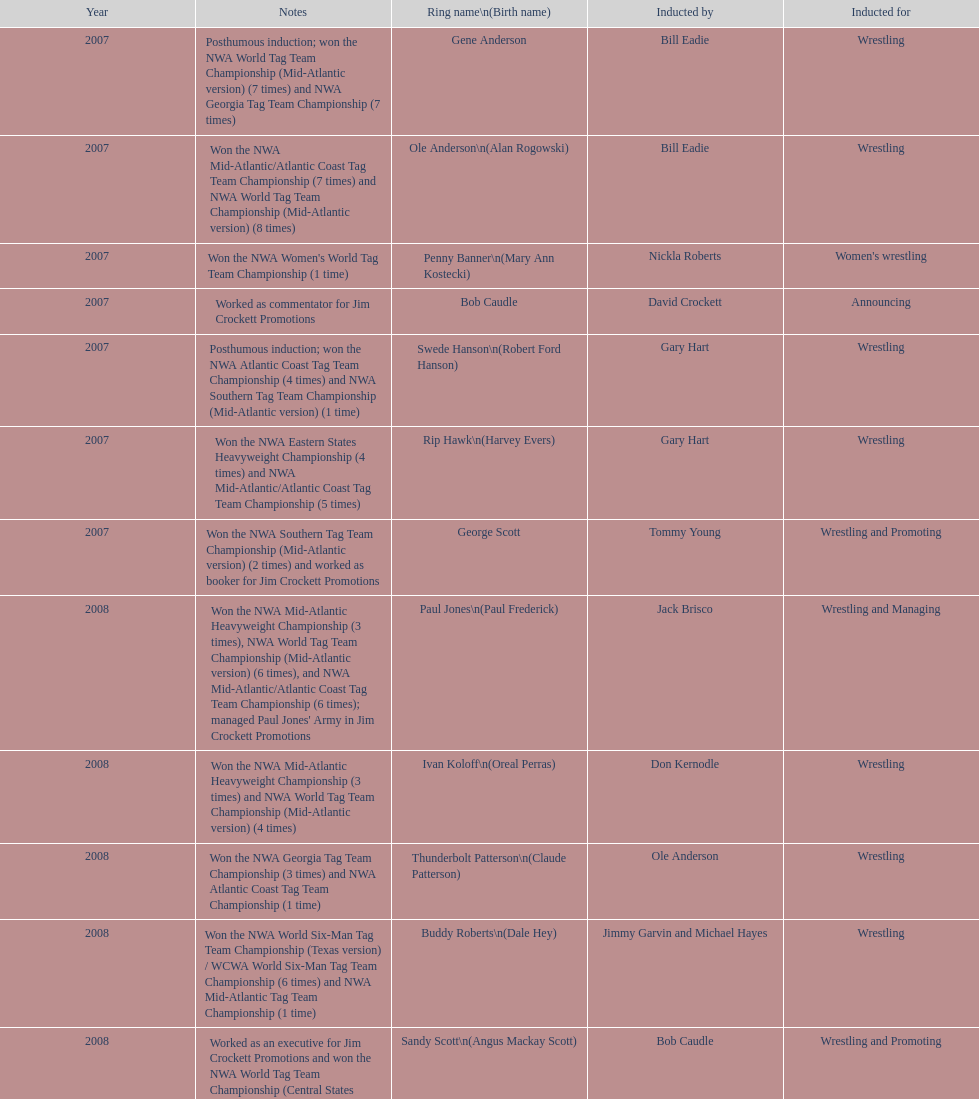Give me the full table as a dictionary. {'header': ['Year', 'Notes', 'Ring name\\n(Birth name)', 'Inducted by', 'Inducted for'], 'rows': [['2007', 'Posthumous induction; won the NWA World Tag Team Championship (Mid-Atlantic version) (7 times) and NWA Georgia Tag Team Championship (7 times)', 'Gene Anderson', 'Bill Eadie', 'Wrestling'], ['2007', 'Won the NWA Mid-Atlantic/Atlantic Coast Tag Team Championship (7 times) and NWA World Tag Team Championship (Mid-Atlantic version) (8 times)', 'Ole Anderson\\n(Alan Rogowski)', 'Bill Eadie', 'Wrestling'], ['2007', "Won the NWA Women's World Tag Team Championship (1 time)", 'Penny Banner\\n(Mary Ann Kostecki)', 'Nickla Roberts', "Women's wrestling"], ['2007', 'Worked as commentator for Jim Crockett Promotions', 'Bob Caudle', 'David Crockett', 'Announcing'], ['2007', 'Posthumous induction; won the NWA Atlantic Coast Tag Team Championship (4 times) and NWA Southern Tag Team Championship (Mid-Atlantic version) (1 time)', 'Swede Hanson\\n(Robert Ford Hanson)', 'Gary Hart', 'Wrestling'], ['2007', 'Won the NWA Eastern States Heavyweight Championship (4 times) and NWA Mid-Atlantic/Atlantic Coast Tag Team Championship (5 times)', 'Rip Hawk\\n(Harvey Evers)', 'Gary Hart', 'Wrestling'], ['2007', 'Won the NWA Southern Tag Team Championship (Mid-Atlantic version) (2 times) and worked as booker for Jim Crockett Promotions', 'George Scott', 'Tommy Young', 'Wrestling and Promoting'], ['2008', "Won the NWA Mid-Atlantic Heavyweight Championship (3 times), NWA World Tag Team Championship (Mid-Atlantic version) (6 times), and NWA Mid-Atlantic/Atlantic Coast Tag Team Championship (6 times); managed Paul Jones' Army in Jim Crockett Promotions", 'Paul Jones\\n(Paul Frederick)', 'Jack Brisco', 'Wrestling and Managing'], ['2008', 'Won the NWA Mid-Atlantic Heavyweight Championship (3 times) and NWA World Tag Team Championship (Mid-Atlantic version) (4 times)', 'Ivan Koloff\\n(Oreal Perras)', 'Don Kernodle', 'Wrestling'], ['2008', 'Won the NWA Georgia Tag Team Championship (3 times) and NWA Atlantic Coast Tag Team Championship (1 time)', 'Thunderbolt Patterson\\n(Claude Patterson)', 'Ole Anderson', 'Wrestling'], ['2008', 'Won the NWA World Six-Man Tag Team Championship (Texas version) / WCWA World Six-Man Tag Team Championship (6 times) and NWA Mid-Atlantic Tag Team Championship (1 time)', 'Buddy Roberts\\n(Dale Hey)', 'Jimmy Garvin and Michael Hayes', 'Wrestling'], ['2008', 'Worked as an executive for Jim Crockett Promotions and won the NWA World Tag Team Championship (Central States version) (1 time) and NWA Southern Tag Team Championship (Mid-Atlantic version) (3 times)', 'Sandy Scott\\n(Angus Mackay Scott)', 'Bob Caudle', 'Wrestling and Promoting'], ['2008', 'Won the NWA United States Tag Team Championship (Tri-State version) (2 times) and NWA Texas Heavyweight Championship (1 time)', 'Grizzly Smith\\n(Aurelian Smith)', 'Magnum T.A.', 'Wrestling'], ['2008', 'Posthumous induction; won the NWA Atlantic Coast/Mid-Atlantic Tag Team Championship (8 times) and NWA Southern Tag Team Championship (Mid-Atlantic version) (6 times)', 'Johnny Weaver\\n(Kenneth Eugene Weaver)', 'Rip Hawk', 'Wrestling'], ['2009', 'Won the NWA Southern Tag Team Championship (Mid-America version) (2 times) and NWA World Tag Team Championship (Mid-America version) (6 times)', 'Don Fargo\\n(Don Kalt)', 'Jerry Jarrett & Steve Keirn', 'Wrestling'], ['2009', 'Won the NWA World Tag Team Championship (Mid-America version) (10 times) and NWA Southern Tag Team Championship (Mid-America version) (22 times)', 'Jackie Fargo\\n(Henry Faggart)', 'Jerry Jarrett & Steve Keirn', 'Wrestling'], ['2009', 'Posthumous induction; won the NWA Southern Tag Team Championship (Mid-America version) (3 times)', 'Sonny Fargo\\n(Jack Lewis Faggart)', 'Jerry Jarrett & Steve Keirn', 'Wrestling'], ['2009', 'Posthumous induction; worked as a booker in World Class Championship Wrestling and managed several wrestlers in Mid-Atlantic Championship Wrestling', 'Gary Hart\\n(Gary Williams)', 'Sir Oliver Humperdink', 'Managing and Promoting'], ['2009', 'Posthumous induction; won the NWA Mid-Atlantic Heavyweight Championship (6 times) and NWA World Tag Team Championship (Mid-Atlantic version) (4 times)', 'Wahoo McDaniel\\n(Edward McDaniel)', 'Tully Blanchard', 'Wrestling'], ['2009', 'Won the NWA Texas Heavyweight Championship (1 time) and NWA World Tag Team Championship (Mid-Atlantic version) (1 time)', 'Blackjack Mulligan\\n(Robert Windham)', 'Ric Flair', 'Wrestling'], ['2009', 'Won the NWA Atlantic Coast Tag Team Championship (2 times)', 'Nelson Royal', 'Brad Anderson, Tommy Angel & David Isley', 'Wrestling'], ['2009', 'Worked as commentator for wrestling events in the Memphis area', 'Lance Russell', 'Dave Brown', 'Announcing']]} Who was inducted after royal? Lance Russell. 